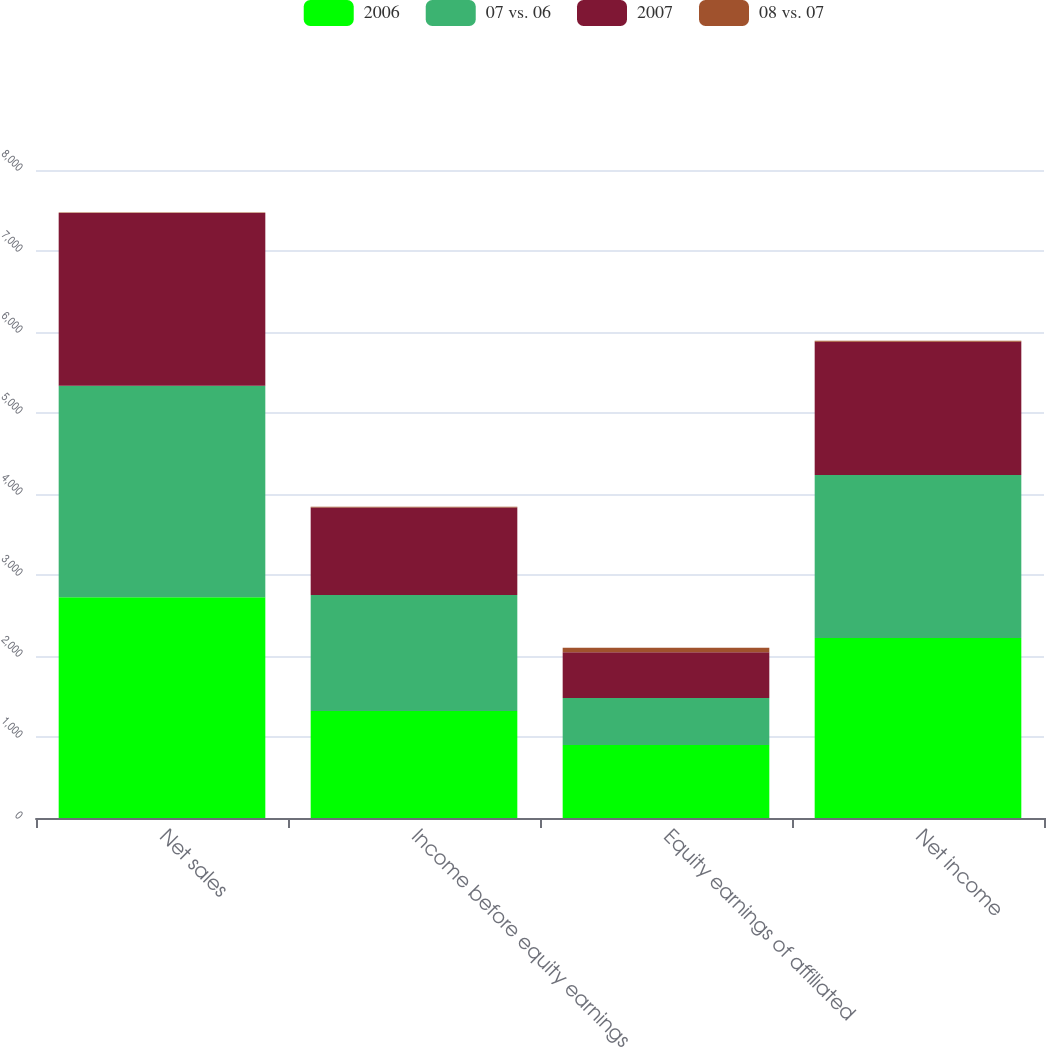Convert chart to OTSL. <chart><loc_0><loc_0><loc_500><loc_500><stacked_bar_chart><ecel><fcel>Net sales<fcel>Income before equity earnings<fcel>Equity earnings of affiliated<fcel>Net income<nl><fcel>2006<fcel>2724<fcel>1321<fcel>900<fcel>2221<nl><fcel>07 vs. 06<fcel>2613<fcel>1433<fcel>582<fcel>2015<nl><fcel>2007<fcel>2133<fcel>1080<fcel>565<fcel>1645<nl><fcel>08 vs. 07<fcel>4<fcel>8<fcel>55<fcel>10<nl></chart> 